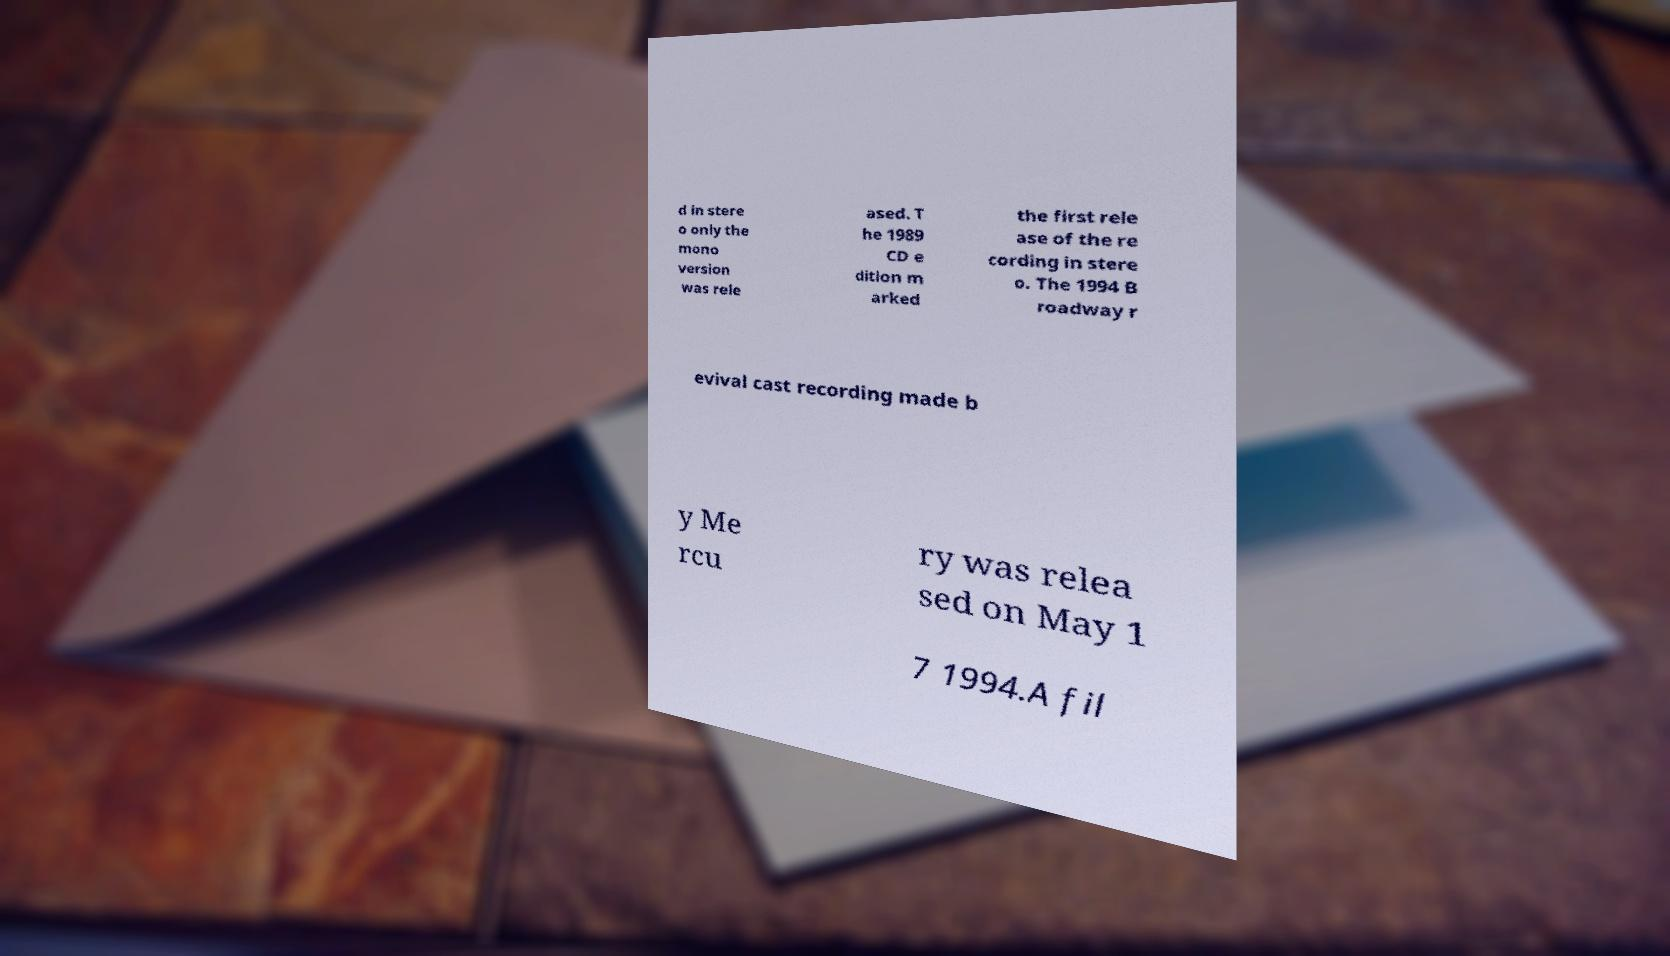Please identify and transcribe the text found in this image. d in stere o only the mono version was rele ased. T he 1989 CD e dition m arked the first rele ase of the re cording in stere o. The 1994 B roadway r evival cast recording made b y Me rcu ry was relea sed on May 1 7 1994.A fil 